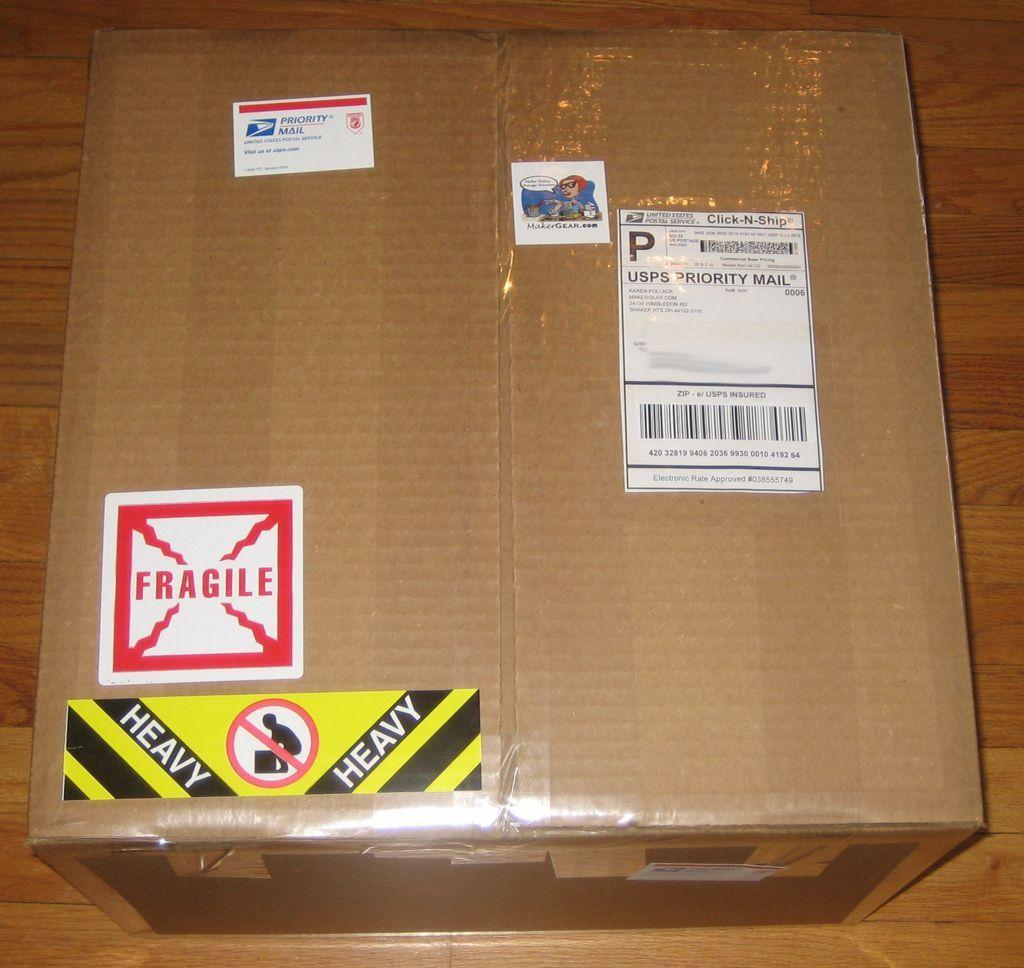Provide a one-sentence caption for the provided image. a unopened box shipped from usps priority mail. 